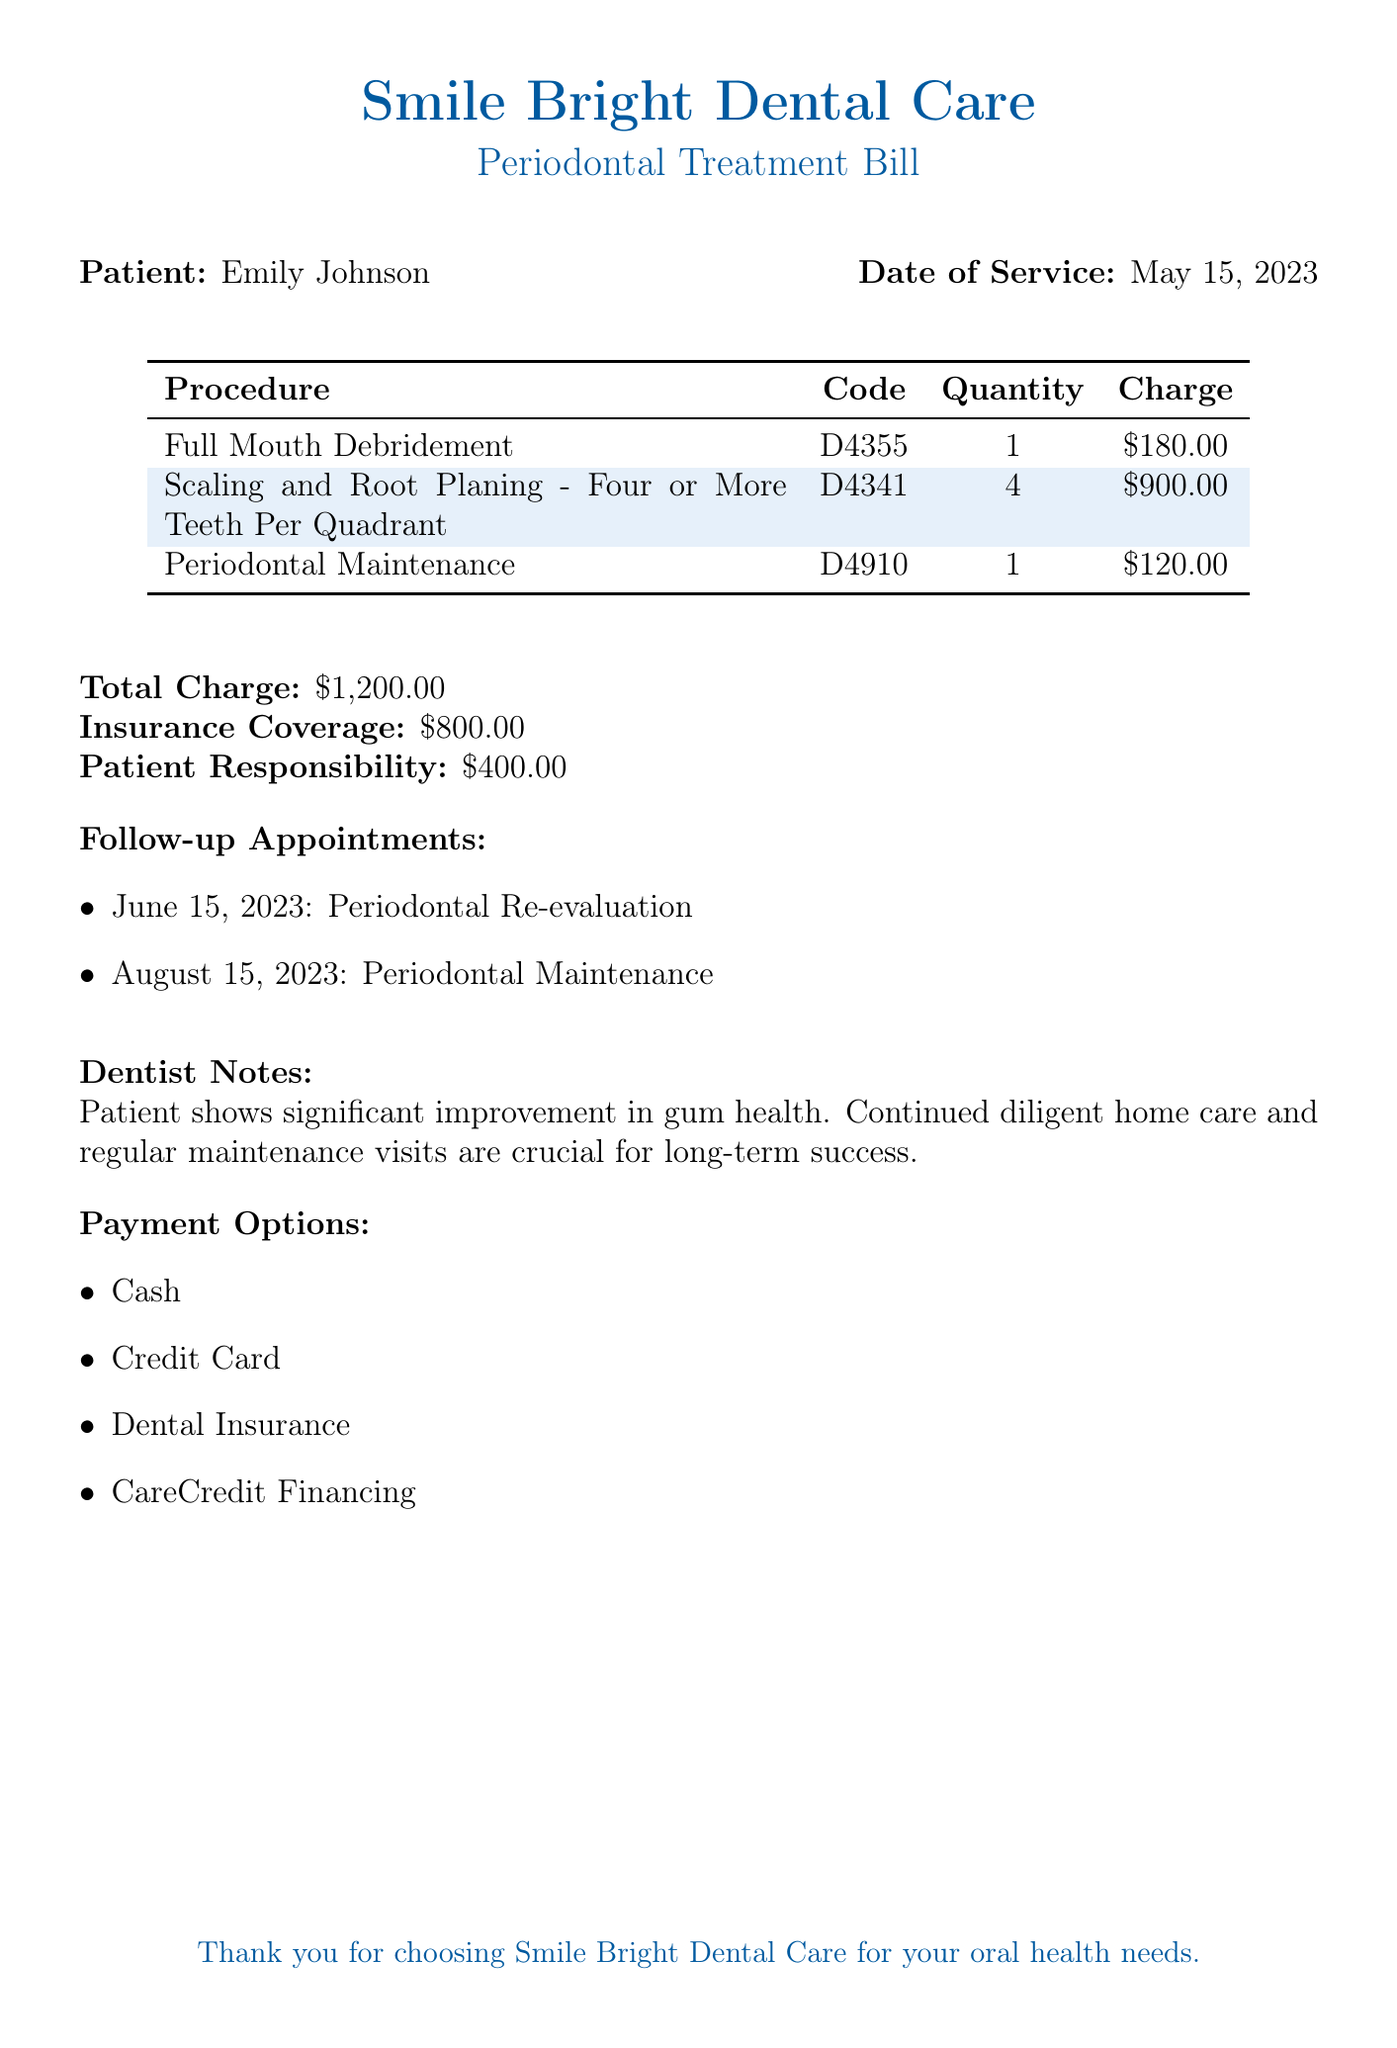What is the patient's name? The document explicitly states the patient's name at the beginning, which is Emily Johnson.
Answer: Emily Johnson What date was the service rendered? The document includes the service date alongside the patient's information, indicating the date of service as May 15, 2023.
Answer: May 15, 2023 What is the charge for Full Mouth Debridement? The bill lists the charges for each procedure, showing that the charge for Full Mouth Debridement is $180.00.
Answer: $180.00 How much is the total charge for the treatment? The total charge indicated at the bottom of the bill sums all the charges, which equals $1,200.00.
Answer: $1,200.00 What is the patient's responsibility after insurance coverage? The document outlines the insurance coverage and the remaining amount that the patient must pay, which is $400.00.
Answer: $400.00 How many follow-up appointments are listed? The document enumerates the follow-up appointments and indicates that there are two scheduled appointments.
Answer: 2 When is the next follow-up appointment? The document specifies the follow-up appointments, with the first one scheduled for June 15, 2023.
Answer: June 15, 2023 What payment options are available? The document provides a list of payment options available for settling the bill, indicating multiple methods such as cash and credit card.
Answer: Cash, Credit Card, Dental Insurance, CareCredit Financing What does the dentist's note emphasize? The dentist's notes in the document emphasize the importance of continued home care and regular maintenance for long-term success.
Answer: Continued diligent home care and regular maintenance visits are crucial 